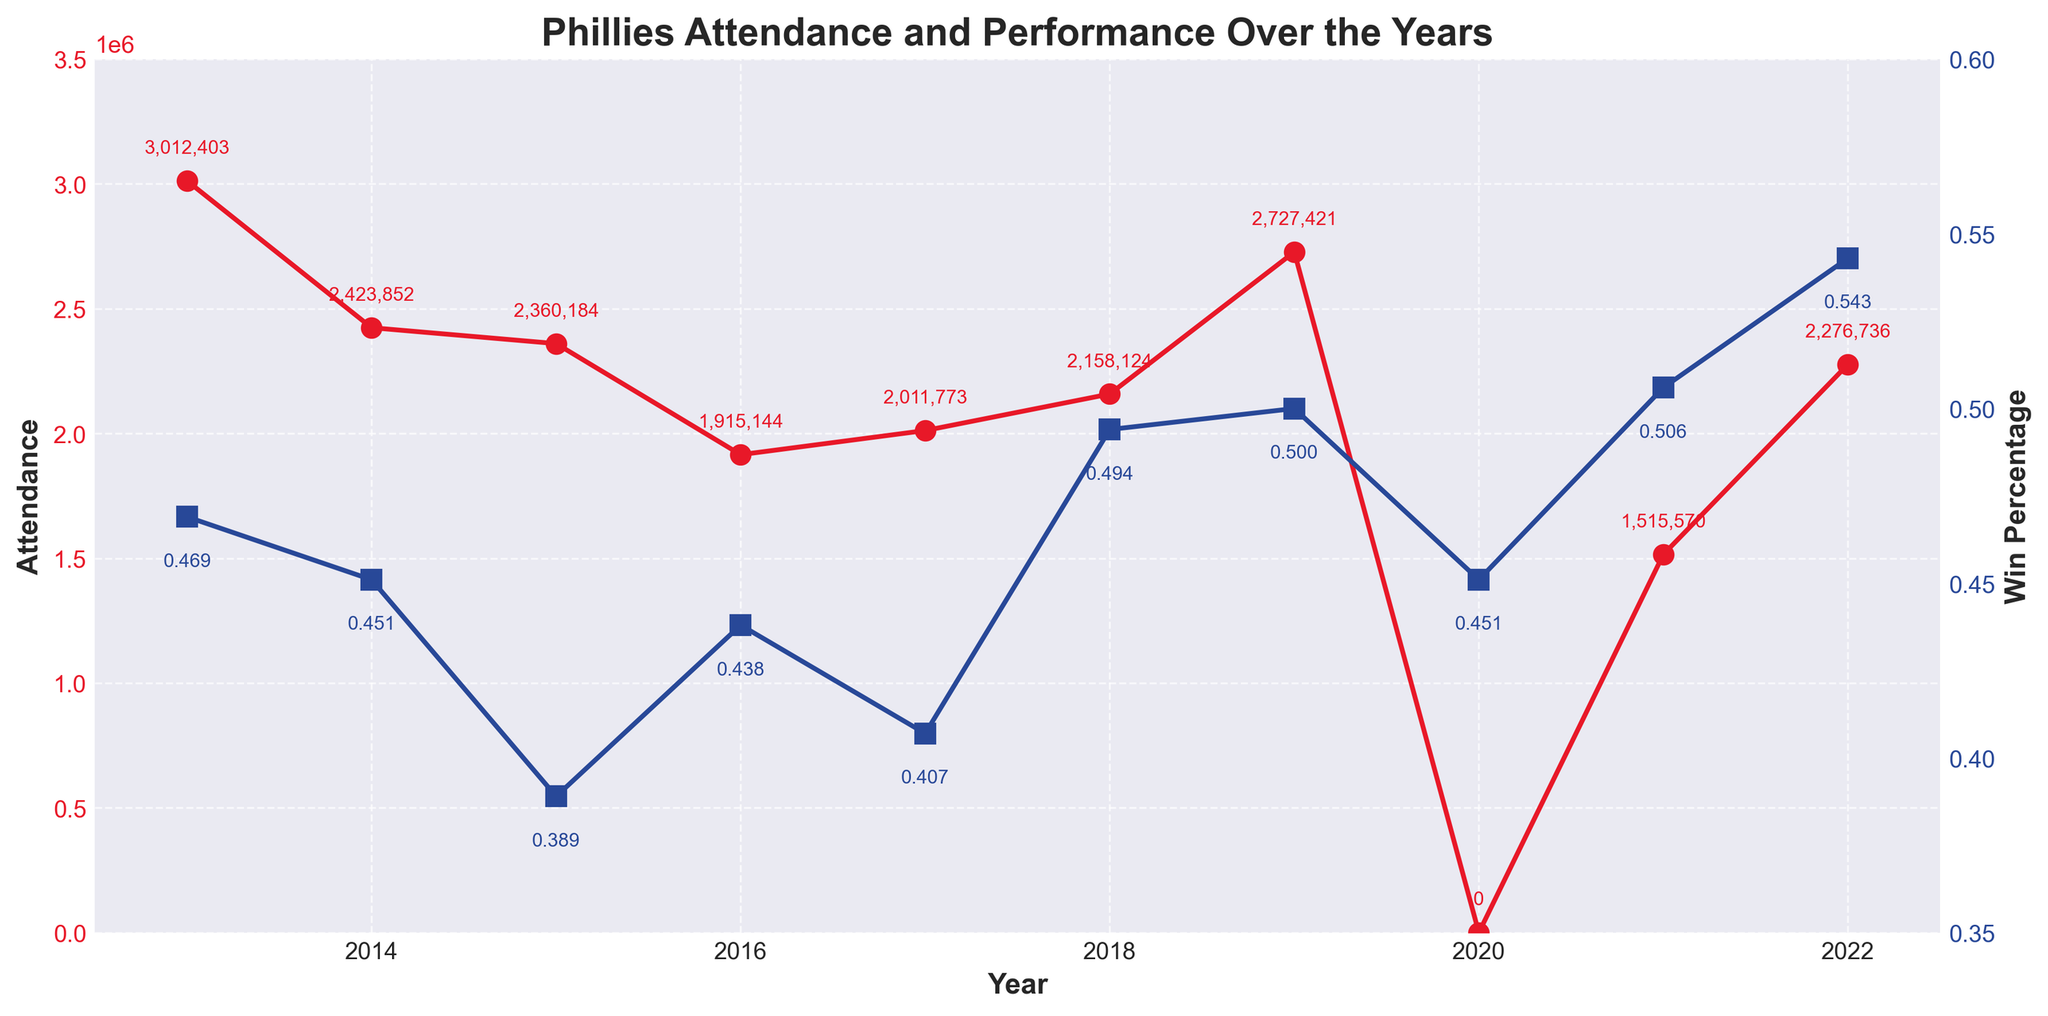What year had the highest attendance? Looking at the red line that represents attendance, the highest point is at 2013 which is marked with a value of 3,012,403.
Answer: 2013 How did the attendance in 2017 compare to 2018? In 2017, the attendance was at 2,011,773 whereas in 2018 it rose to 2,158,124. This shows an increase from 2017 to 2018.
Answer: Increased What is the correlation between win percentage and attendance in 2019? In 2019, the win percentage was 0.500 and the attendance was 2,727,421. This indicates a positive relationship where an average to high win percentage corresponds to a relatively high attendance.
Answer: Positive correlation Which year had the lowest win percentage, and how did that year's attendance compare to other years? The lowest win percentage was in 2015 at 0.389, and its attendance was 2,360,184. This is relatively higher than the attendance in years like 2016 and 2017 despite having the lowest win percentage.
Answer: 2015, attendance relatively higher despite low win percentage Was there a year where the attendance was zero? If so, what could be the reason? Yes, in 2020 the attendance was zero. This was likely due to the COVID-19 pandemic restrictions on public gatherings.
Answer: 2020, due to COVID-19 What is the average attendance over the decade? Sum up the attendance from 2013 to 2022 and divide by 10 (since 2020 had zero attendance). The total is 2,012,403 + 2,423,852 + 2,360,184 + 1,915,144 + 2,011,773 + 2,158,124 + 2,727,421 + 0 + 1,515,570 + 2,276,736 = 18,401,207. Divide by 10 to get 1,840,121.
Answer: 1,840,121 How did the 2022 win percentage compare to the previous years? The win percentage in 2022 was 0.543, which was the highest win percentage throughout the decade, indicating a strong performance.
Answer: Highest in the decade Why might there be a significant drop in attendance from 2013 to 2014? The attendance dropped from 3,012,403 in 2013 to 2,423,852 in 2014. This could be correlated to the decline in win percentage from 0.469 to 0.451, indicating team performance could influence fan turnout.
Answer: Decline in team performance What year had the smallest attendance and what might have contributed to it? The smallest attendance was in 2021 with 1,515,570. This could be attributed to ongoing COVID-19 restrictions and the recovery phase post-pandemic.
Answer: 2021, post-pandemic recovery Calculate the change in attendance from the year with the highest win percentage to the one with the lowest. The highest win percentage (0.543) in 2022 had an attendance of 2,276,736. The lowest win percentage (0.389) in 2015 had an attendance of 2,360,184. The change in attendance is 2,276,736 - 2,360,184 = -83,448.
Answer: Decrease of 83,448 